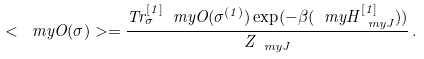<formula> <loc_0><loc_0><loc_500><loc_500>< \ m y O ( \sigma ) > = \frac { T r _ { \sigma } ^ { [ 1 ] } \ m y O ( \sigma ^ { ( 1 ) } ) \exp ( - \beta ( \ m y H ^ { [ 1 ] } _ { \ m y J } ) ) } { Z _ { \ m y J } } \, .</formula> 